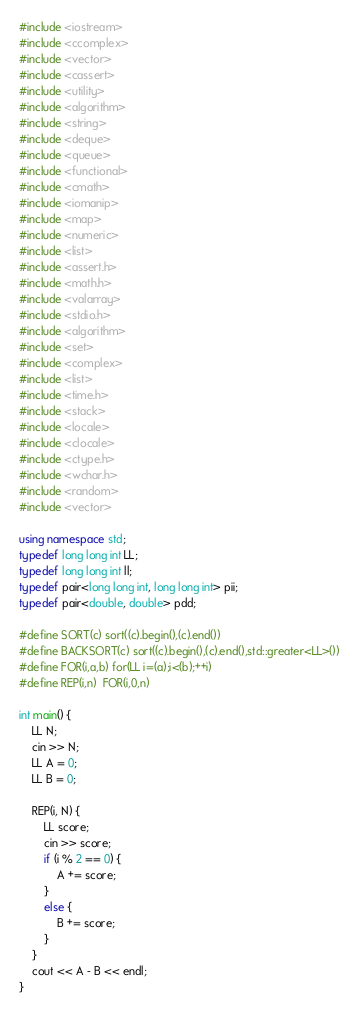Convert code to text. <code><loc_0><loc_0><loc_500><loc_500><_C++_>#include <iostream>
#include <ccomplex>
#include <vector>
#include <cassert>
#include <utility>
#include <algorithm>
#include <string>
#include <deque>
#include <queue>
#include <functional>
#include <cmath>
#include <iomanip>
#include <map>
#include <numeric>
#include <list>
#include <assert.h>
#include <math.h>
#include <valarray>
#include <stdio.h>
#include <algorithm>
#include <set>
#include <complex>
#include <list>
#include <time.h>
#include <stack>
#include <locale>
#include <clocale>
#include <ctype.h>
#include <wchar.h>
#include <random>
#include <vector>

using namespace std;
typedef long long int LL;
typedef long long int ll;
typedef pair<long long int, long long int> pii;
typedef pair<double, double> pdd;

#define SORT(c) sort((c).begin(),(c).end())
#define BACKSORT(c) sort((c).begin(),(c).end(),std::greater<LL>())
#define FOR(i,a,b) for(LL i=(a);i<(b);++i)
#define REP(i,n)  FOR(i,0,n)

int main() {
	LL N;
	cin >> N;
	LL A = 0;
	LL B = 0;

	REP(i, N) {
		LL score;
		cin >> score;
		if (i % 2 == 0) {
			A += score;
		}
		else {
			B += score;
		}
	}
	cout << A - B << endl;
}</code> 